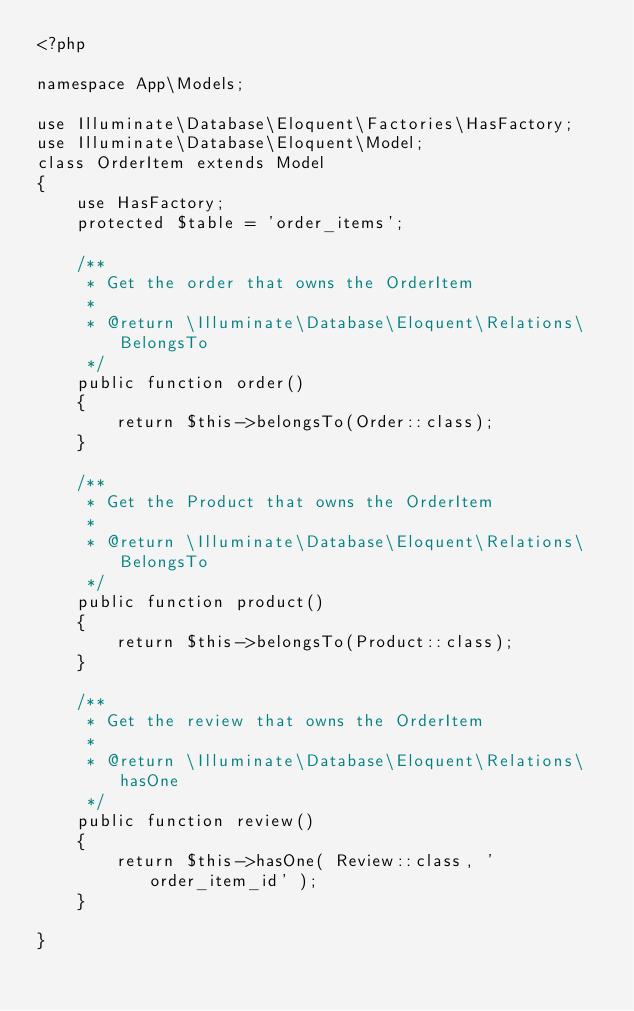<code> <loc_0><loc_0><loc_500><loc_500><_PHP_><?php

namespace App\Models;

use Illuminate\Database\Eloquent\Factories\HasFactory;
use Illuminate\Database\Eloquent\Model;
class OrderItem extends Model
{
    use HasFactory;
    protected $table = 'order_items';

    /**
     * Get the order that owns the OrderItem
     *
     * @return \Illuminate\Database\Eloquent\Relations\BelongsTo
     */
    public function order()
    {
        return $this->belongsTo(Order::class);
    }

    /**
     * Get the Product that owns the OrderItem
     *
     * @return \Illuminate\Database\Eloquent\Relations\BelongsTo
     */
    public function product()
    {
        return $this->belongsTo(Product::class);
    }

    /**
     * Get the review that owns the OrderItem
     *
     * @return \Illuminate\Database\Eloquent\Relations\hasOne
     */
    public function review()
    {
        return $this->hasOne( Review::class, 'order_item_id' );
    }

}
</code> 